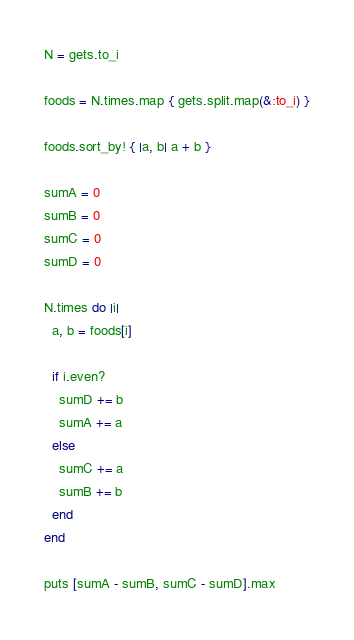<code> <loc_0><loc_0><loc_500><loc_500><_Ruby_>N = gets.to_i

foods = N.times.map { gets.split.map(&:to_i) }

foods.sort_by! { |a, b| a + b }

sumA = 0
sumB = 0
sumC = 0
sumD = 0

N.times do |i|
  a, b = foods[i]

  if i.even?
    sumD += b
    sumA += a
  else
    sumC += a
    sumB += b
  end
end

puts [sumA - sumB, sumC - sumD].max
</code> 